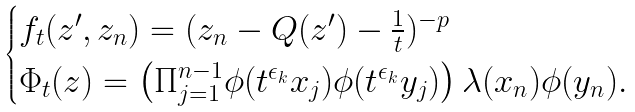Convert formula to latex. <formula><loc_0><loc_0><loc_500><loc_500>\begin{cases} f _ { t } ( z ^ { \prime } , z _ { n } ) = ( z _ { n } - Q ( z ^ { \prime } ) - \frac { 1 } { t } ) ^ { - p } \\ \Phi _ { t } ( z ) = \left ( \Pi _ { j = 1 } ^ { n - 1 } \phi ( t ^ { \epsilon _ { k } } x _ { j } ) \phi ( t ^ { \epsilon _ { k } } y _ { j } ) \right ) \lambda ( x _ { n } ) \phi ( y _ { n } ) . \end{cases}</formula> 